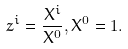<formula> <loc_0><loc_0><loc_500><loc_500>z ^ { i } = \frac { X ^ { i } } { X ^ { 0 } } , X ^ { 0 } = 1 .</formula> 